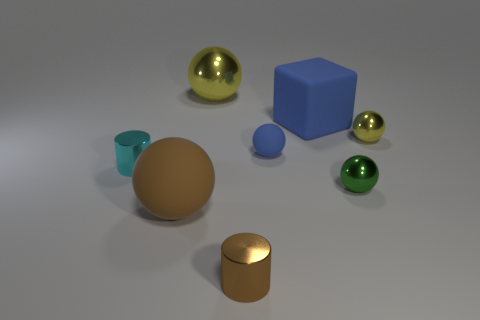Add 2 big yellow things. How many objects exist? 10 Subtract all rubber balls. How many balls are left? 3 Subtract 0 gray cubes. How many objects are left? 8 Subtract all blocks. How many objects are left? 7 Subtract 2 cylinders. How many cylinders are left? 0 Subtract all gray cylinders. Subtract all green blocks. How many cylinders are left? 2 Subtract all blue cylinders. How many red balls are left? 0 Subtract all blue matte cubes. Subtract all tiny green cylinders. How many objects are left? 7 Add 1 big blocks. How many big blocks are left? 2 Add 7 large metallic objects. How many large metallic objects exist? 8 